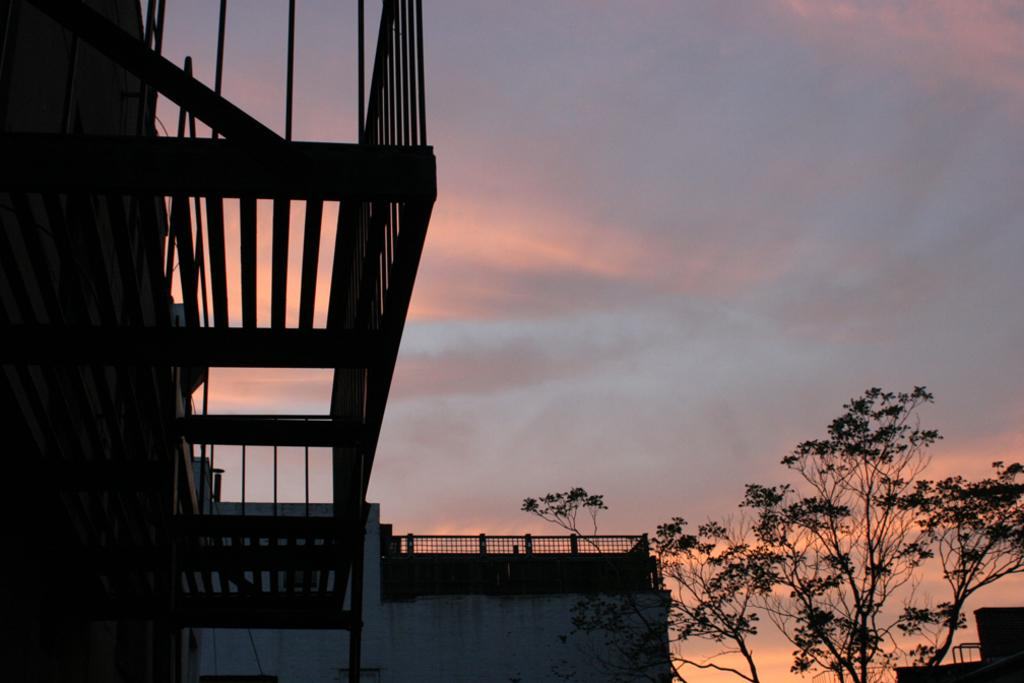What is the main structure in the picture? There is a building in the picture. What type of vegetation is on the left side of the picture? There is a tree on the left side of the picture. What is the condition of the sky in the picture? The sky is clear in the picture. Can you tell me how many times the house has been burned down in the image? There is no house present in the image, and therefore no information about it being burned down. What type of comb is being used by the tree in the image? There is no comb present in the image, and the tree is not using any comb. 